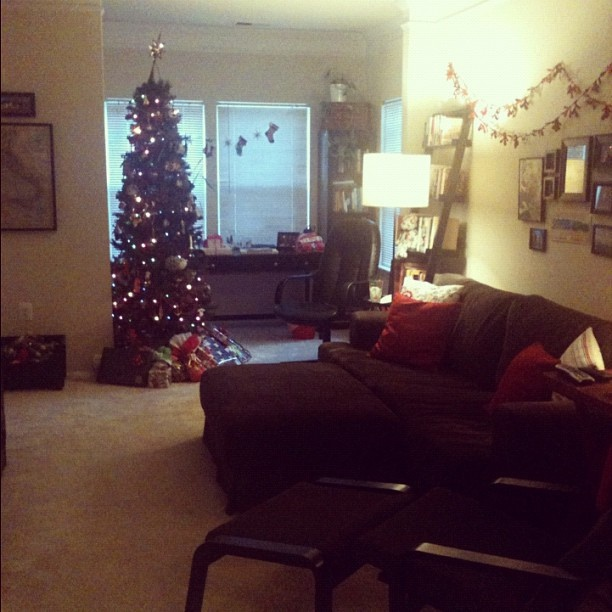Describe the objects in this image and their specific colors. I can see chair in black, maroon, and brown tones, couch in black, maroon, beige, and brown tones, chair in black, gray, and purple tones, book in black, darkgray, and gray tones, and potted plant in black, darkgray, and gray tones in this image. 